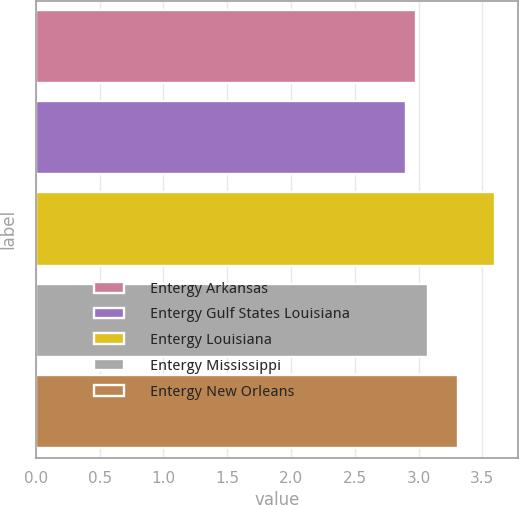Convert chart. <chart><loc_0><loc_0><loc_500><loc_500><bar_chart><fcel>Entergy Arkansas<fcel>Entergy Gulf States Louisiana<fcel>Entergy Louisiana<fcel>Entergy Mississippi<fcel>Entergy New Orleans<nl><fcel>2.98<fcel>2.9<fcel>3.6<fcel>3.07<fcel>3.31<nl></chart> 